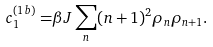Convert formula to latex. <formula><loc_0><loc_0><loc_500><loc_500>c _ { 1 } ^ { ( 1 b ) } = & \beta J \sum _ { n } ( n + 1 ) ^ { 2 } \rho _ { n } \rho _ { n + 1 } .</formula> 